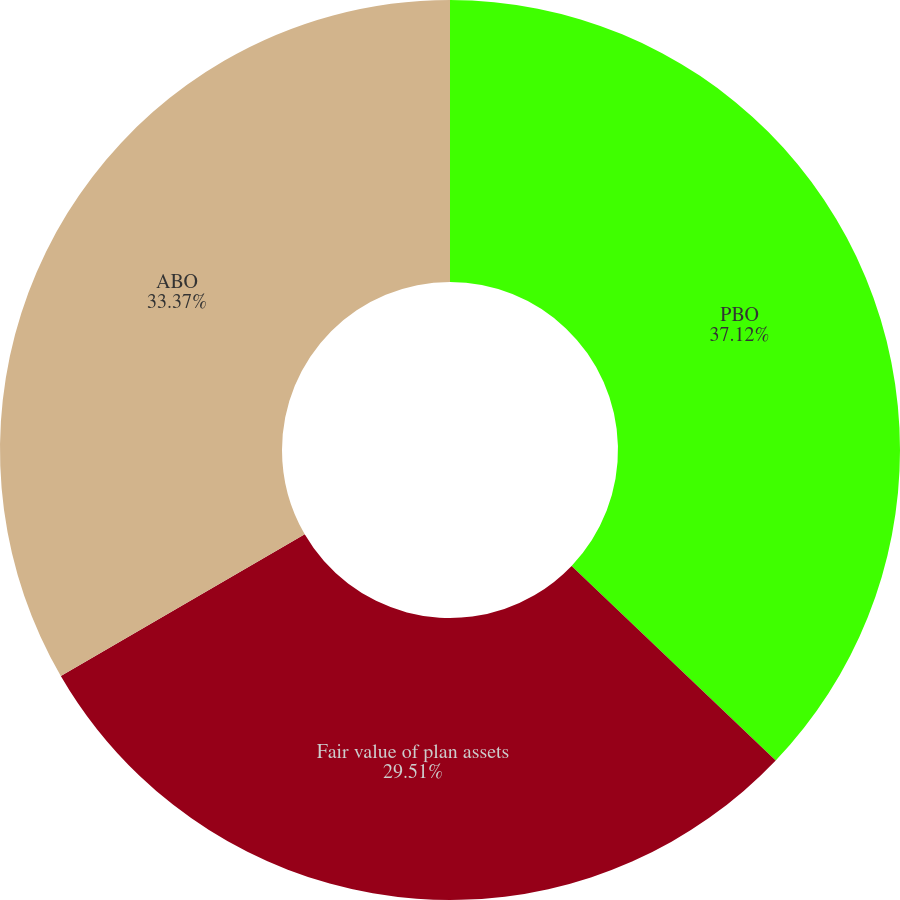Convert chart to OTSL. <chart><loc_0><loc_0><loc_500><loc_500><pie_chart><fcel>PBO<fcel>Fair value of plan assets<fcel>ABO<nl><fcel>37.12%<fcel>29.51%<fcel>33.37%<nl></chart> 